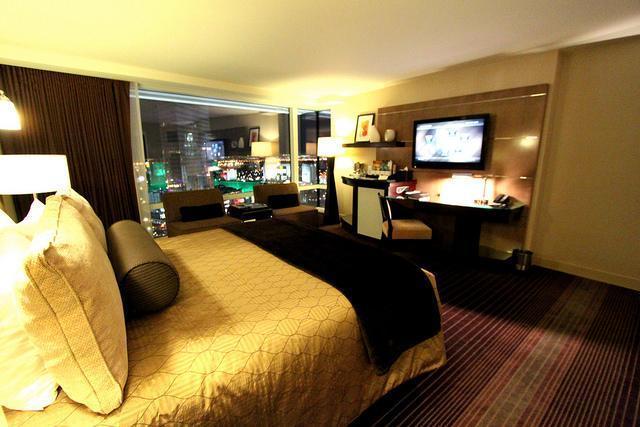How many pillows are on the bed?
Give a very brief answer. 5. 